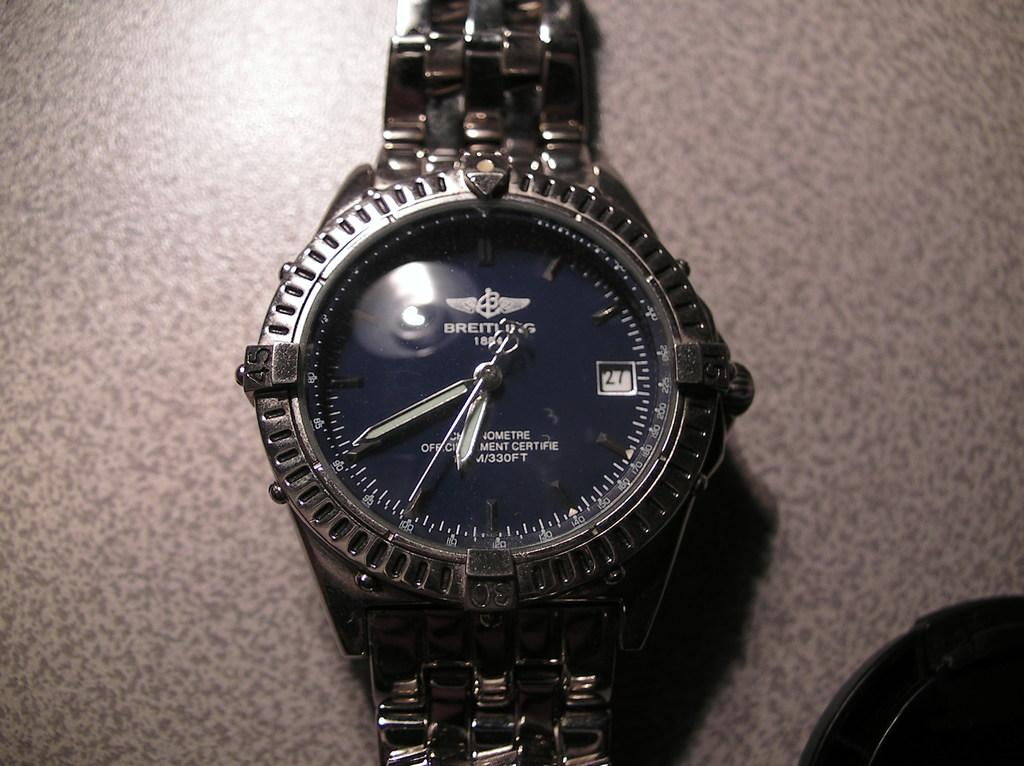<image>
Create a compact narrative representing the image presented. A black watch that is made by the brand Breitlug. 